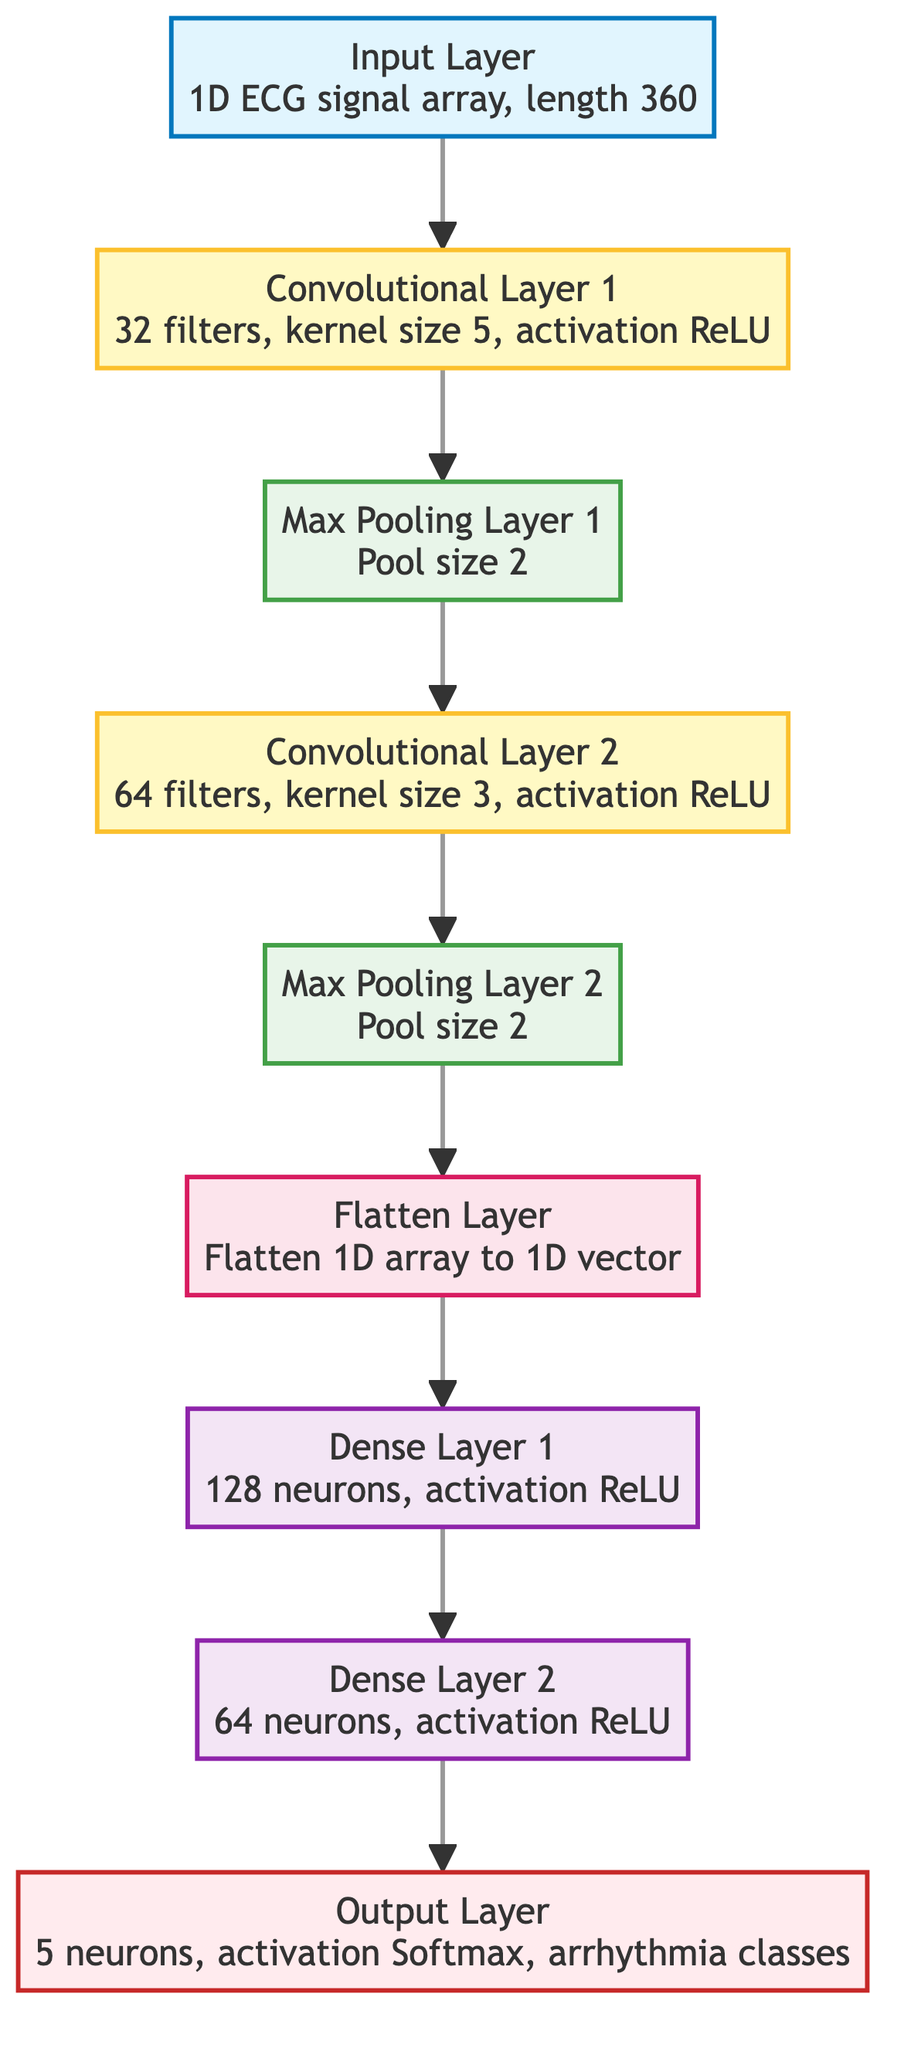What is the length of the input signal in the diagram? The input layer specifies that the length of the 1D ECG signal array is 360. This is directly stated in the text within the input_layer node.
Answer: 360 How many filters are used in Convolutional Layer 1? The diagram shows that Convolutional Layer 1 uses 32 filters. This information is found in the description within the conv_layer_1 node.
Answer: 32 What is the activation function used in Dense Layer 2? The diagram indicates that the activation function for Dense Layer 2 is ReLU, as noted in the description of the dense_layer_2 node.
Answer: ReLU Which layer comes after Max Pooling Layer 1? The flow of the diagram indicates that after Max Pooling Layer 1, the next layer is Convolutional Layer 2, as observed from the arrows pointing from pooling_layer_1 to conv_layer_2.
Answer: Convolutional Layer 2 What is the number of neurons in the Output Layer? The Output Layer is specified to have 5 neurons, which is detailed in the output_layer node description. This is a critical aspect of the diagram, denoting the number of arrhythmia classes.
Answer: 5 How many convolutional layers are present in the architecture? By reviewing the diagram, we see there are two distinct layers labeled as convolutional layers (Convolutional Layer 1 and Convolutional Layer 2), making the total number two.
Answer: 2 What is the pool size used in Max Pooling Layer 2? The diagram shows that the pool size for Max Pooling Layer 2 is 2, specified in the information within pooling_layer_2.
Answer: 2 What is the purpose of the Flatten Layer in the architecture? The Flatten Layer's purpose is to flatten the 1D array into a 1D vector, as stated directly in the description of the flatten_layer node. This step prepares the data for the following dense layers.
Answer: Flatten 1D array to 1D vector How many layers are between the Input Layer and the Output Layer? There are multiple layers in the architecture, specifically four layers (Convolutional Layer 1, Max Pooling Layer 1, Convolutional Layer 2, and Max Pooling Layer 2) followed by the Flatten Layer and then two Dense Layers before reaching the Output Layer, resulting in a total of six layers.
Answer: 6 